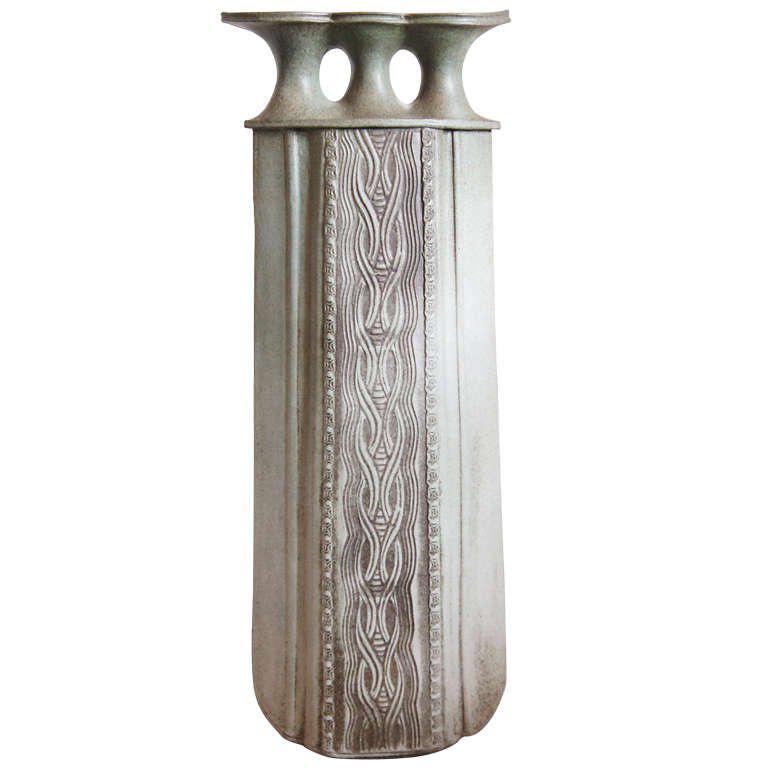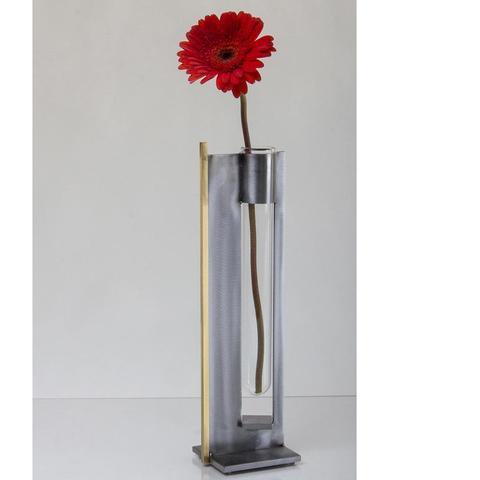The first image is the image on the left, the second image is the image on the right. Examine the images to the left and right. Is the description "All vases are the same green color with a drip effect, and no vases have handles." accurate? Answer yes or no. No. The first image is the image on the left, the second image is the image on the right. Evaluate the accuracy of this statement regarding the images: "One vase is mostly dark green while the other has a lot more lighter green on it.". Is it true? Answer yes or no. No. 